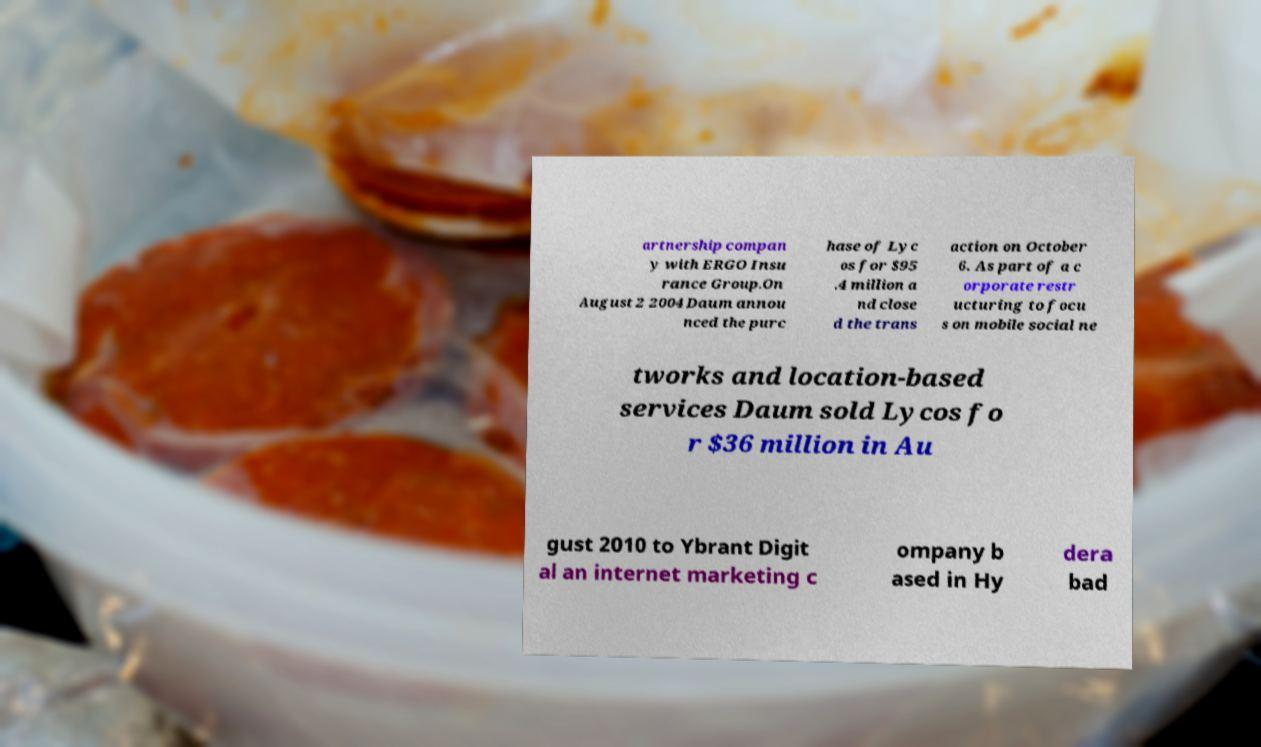Could you assist in decoding the text presented in this image and type it out clearly? artnership compan y with ERGO Insu rance Group.On August 2 2004 Daum annou nced the purc hase of Lyc os for $95 .4 million a nd close d the trans action on October 6. As part of a c orporate restr ucturing to focu s on mobile social ne tworks and location-based services Daum sold Lycos fo r $36 million in Au gust 2010 to Ybrant Digit al an internet marketing c ompany b ased in Hy dera bad 